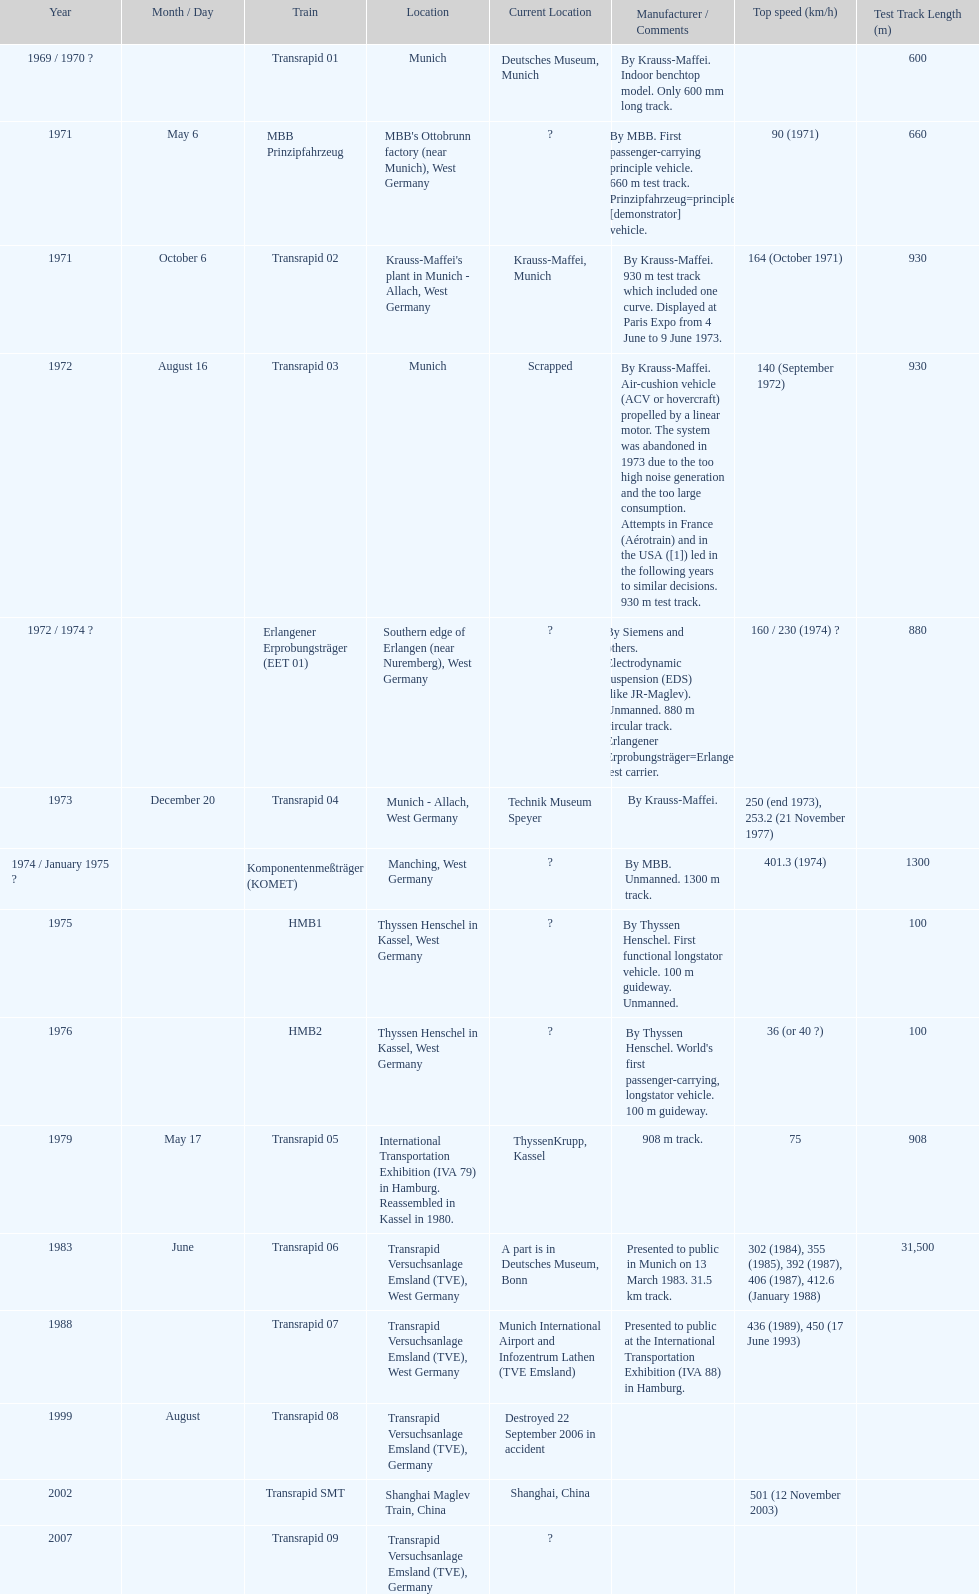Which train has the least top speed? HMB2. 